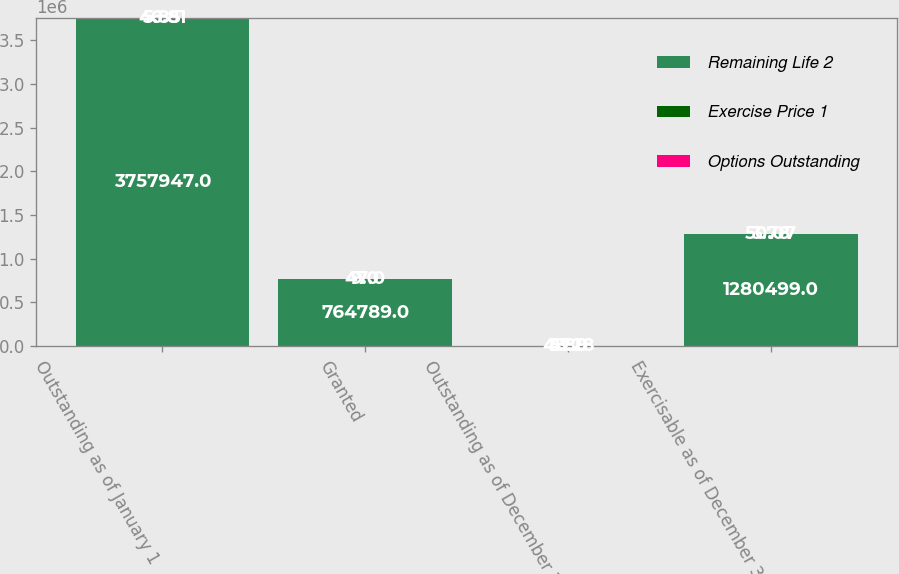Convert chart. <chart><loc_0><loc_0><loc_500><loc_500><stacked_bar_chart><ecel><fcel>Outstanding as of January 1<fcel>Granted<fcel>Outstanding as of December 31<fcel>Exercisable as of December 31<nl><fcel>Remaining Life 2<fcel>3.75795e+06<fcel>764789<fcel>47<fcel>1.2805e+06<nl><fcel>Exercise Price 1<fcel>46.81<fcel>47<fcel>48.28<fcel>50.07<nl><fcel>Options Outstanding<fcel>5.85<fcel>9<fcel>5.89<fcel>3.78<nl></chart> 